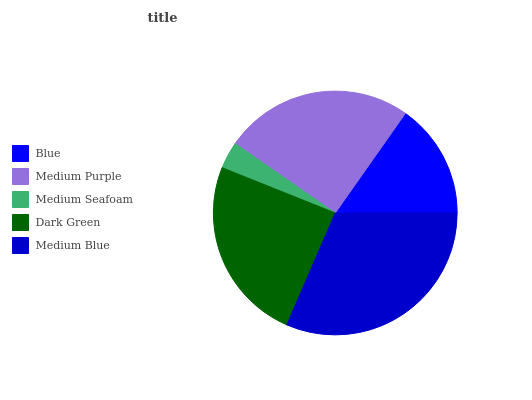Is Medium Seafoam the minimum?
Answer yes or no. Yes. Is Medium Blue the maximum?
Answer yes or no. Yes. Is Medium Purple the minimum?
Answer yes or no. No. Is Medium Purple the maximum?
Answer yes or no. No. Is Medium Purple greater than Blue?
Answer yes or no. Yes. Is Blue less than Medium Purple?
Answer yes or no. Yes. Is Blue greater than Medium Purple?
Answer yes or no. No. Is Medium Purple less than Blue?
Answer yes or no. No. Is Dark Green the high median?
Answer yes or no. Yes. Is Dark Green the low median?
Answer yes or no. Yes. Is Medium Purple the high median?
Answer yes or no. No. Is Medium Blue the low median?
Answer yes or no. No. 